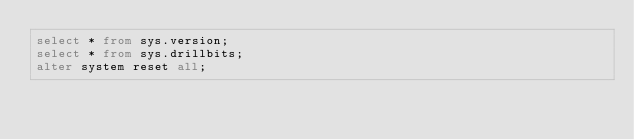Convert code to text. <code><loc_0><loc_0><loc_500><loc_500><_SQL_>select * from sys.version;
select * from sys.drillbits;
alter system reset all;
</code> 